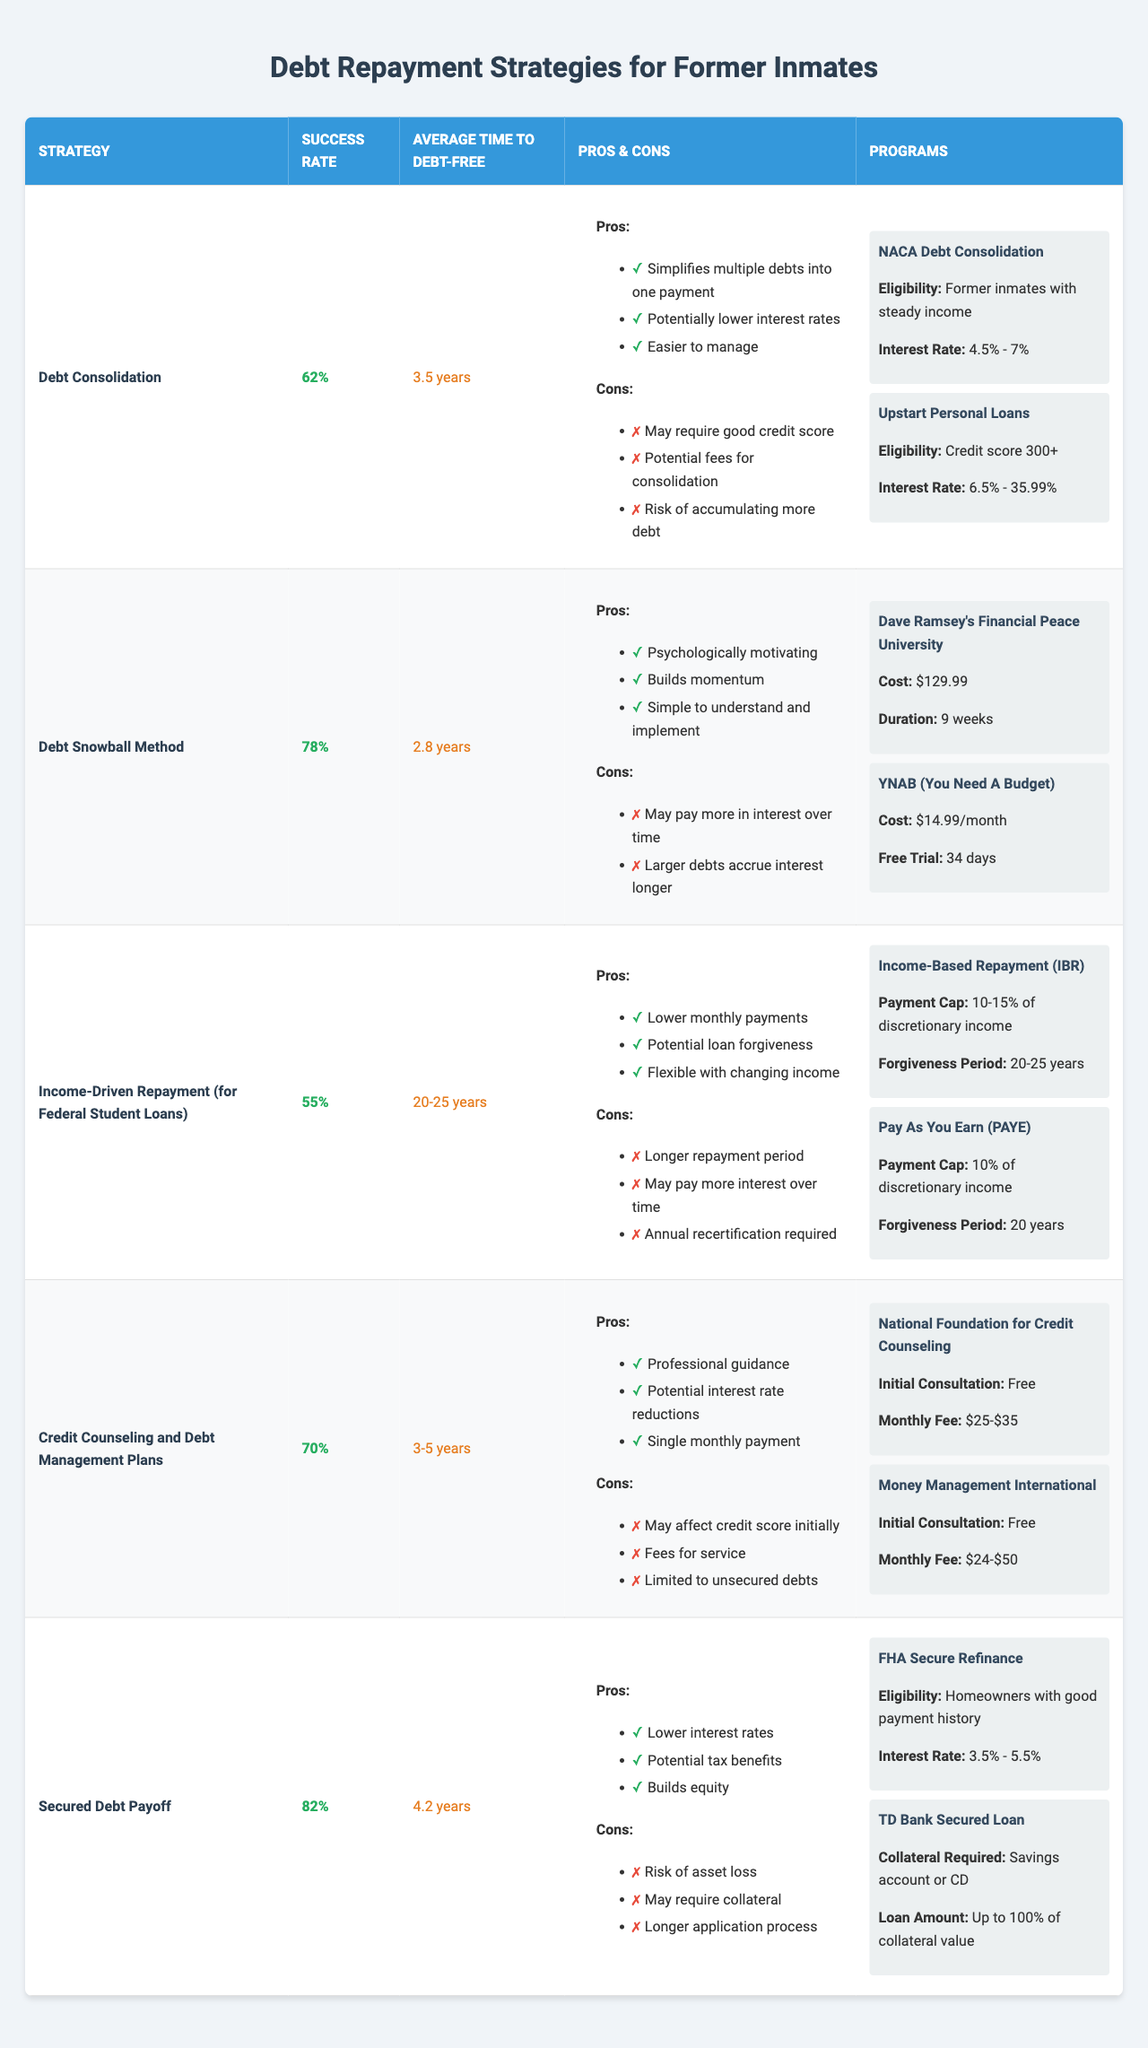What is the success rate of the Debt Snowball Method? The Debt Snowball Method has a listed success rate in the table. By checking the "Success Rate" column, we see it is stated as 78%.
Answer: 78% Which repayment strategy has the longest average time to debt-free? Looking at the "Average Time to Debt-Free" column, "Income-Driven Repayment (for Federal Student Loans)" has the longest average time listed as 20-25 years.
Answer: 20-25 years What are the pros of utilizing Credit Counseling and Debt Management Plans? The pros are listed directly under the "Pros & Cons" column for this strategy. The pros include: Professional guidance, Potential interest rate reductions, and Single monthly payment.
Answer: Professional guidance, Potential interest rate reductions, Single monthly payment Is the average time to debt-free shorter for the Secured Debt Payoff strategy compared to Debt Snowball Method? The average time for the Secured Debt Payoff is 4.2 years, while for the Debt Snowball Method, it is 2.8 years. Since 4.2 years is greater than 2.8 years, the Secured Debt Payoff has a longer time to debt-free.
Answer: No Which strategy offers the lowest success rate? By comparing all the success rates in the table, the Income-Driven Repayment strategy has the lowest success rate at 55%.
Answer: 55% How many strategies have a success rate of over 70%? We can refer to the "Success Rate" column and identify the strategies above 70%: Debt Snowball Method (78%), Credit Counseling and Debt Management Plans (70%), and Secured Debt Payoff (82%). This makes a total of three strategies.
Answer: 3 Which repayment strategy has the largest difference between its success rate and the average time to debt-free? We find the success rate and the average time for each strategy. The two strategies with the highest gap are "Income-Driven Repayment (for Federal Student Loans)" (Success Rate: 55%, Average Time: 20-25 years) and "Debt Snowball Method" (Success Rate: 78%, Average Time: 2.8 years). The largest difference when considering the time, which is quantified crudely in years, is clearly the Income-Driven Repayment due to its lengthy repayment period versus its lower success.
Answer: Income-Driven Repayment Does the Debt Consolidation strategy require a good credit score? The cons listed for Debt Consolidation indicate that it may require a good credit score. Thus, we confirm that this strategy does indeed have this requirement.
Answer: Yes What is the average time to debt-free for strategies with a success rate over 70%? The strategies with success rates over 70% are Debt Snowball Method (2.8 years), Credit Counseling and Debt Management Plans (3-5 years), and Secured Debt Payoff (4.2 years). We convert 3-5 years to an average of 4 years. Then, summing the values (2.8 + 4 + 4.2) and dividing by 3 gives us a total average of about 3.67 years.
Answer: 3.67 years 